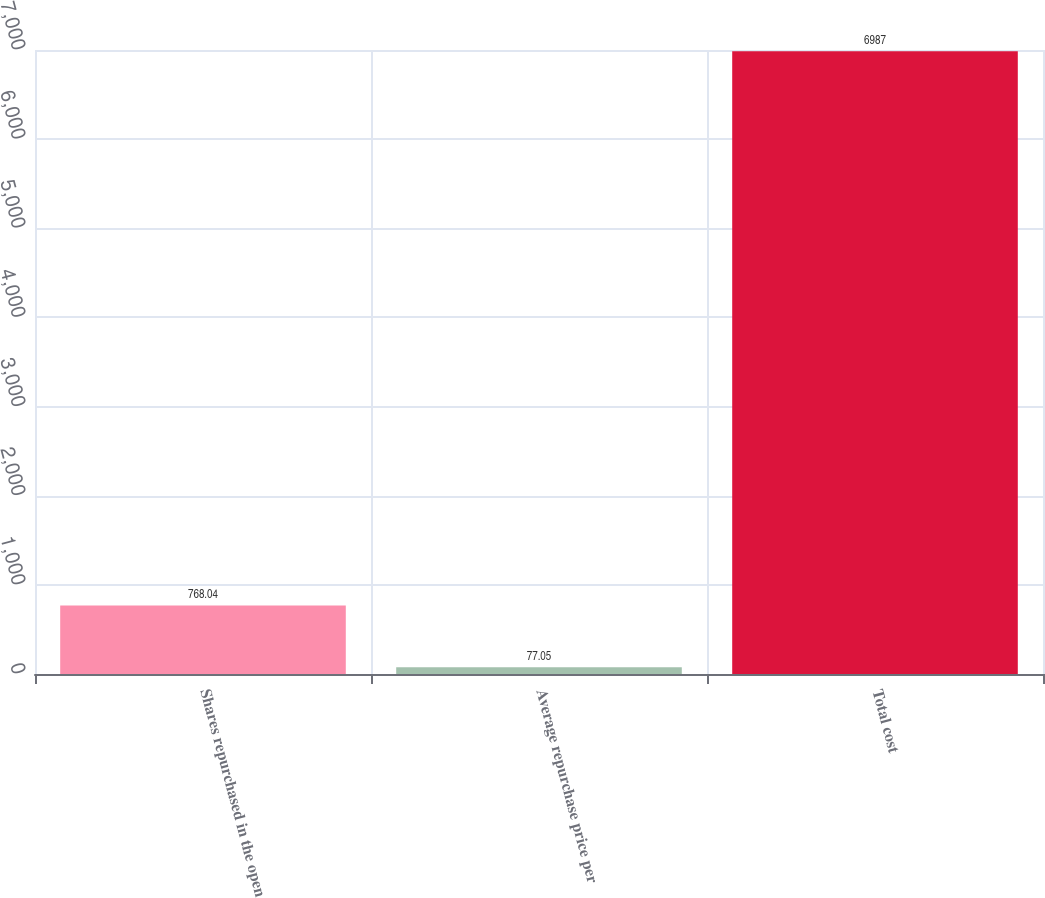Convert chart to OTSL. <chart><loc_0><loc_0><loc_500><loc_500><bar_chart><fcel>Shares repurchased in the open<fcel>Average repurchase price per<fcel>Total cost<nl><fcel>768.04<fcel>77.05<fcel>6987<nl></chart> 